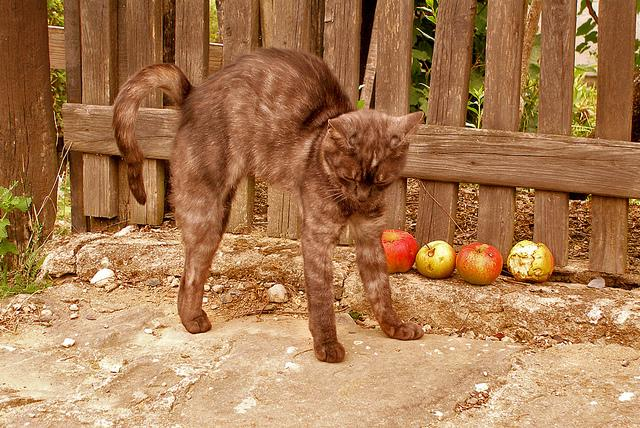What is the most popular type of apple? Please explain your reasoning. red delicious. The red delicious apple is one that most people know. 